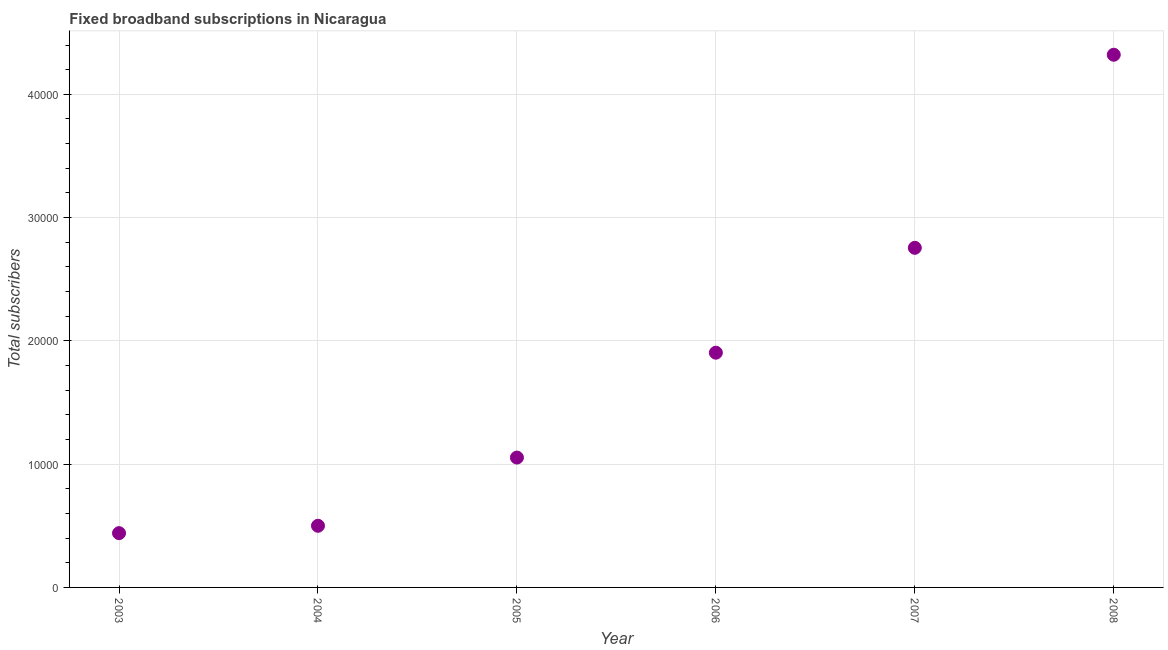What is the total number of fixed broadband subscriptions in 2008?
Your answer should be compact. 4.32e+04. Across all years, what is the maximum total number of fixed broadband subscriptions?
Give a very brief answer. 4.32e+04. Across all years, what is the minimum total number of fixed broadband subscriptions?
Keep it short and to the point. 4403. In which year was the total number of fixed broadband subscriptions maximum?
Your response must be concise. 2008. In which year was the total number of fixed broadband subscriptions minimum?
Give a very brief answer. 2003. What is the sum of the total number of fixed broadband subscriptions?
Provide a short and direct response. 1.10e+05. What is the difference between the total number of fixed broadband subscriptions in 2003 and 2006?
Offer a terse response. -1.46e+04. What is the average total number of fixed broadband subscriptions per year?
Make the answer very short. 1.83e+04. What is the median total number of fixed broadband subscriptions?
Your answer should be compact. 1.48e+04. What is the ratio of the total number of fixed broadband subscriptions in 2003 to that in 2004?
Provide a succinct answer. 0.88. Is the total number of fixed broadband subscriptions in 2004 less than that in 2007?
Your response must be concise. Yes. Is the difference between the total number of fixed broadband subscriptions in 2003 and 2008 greater than the difference between any two years?
Keep it short and to the point. Yes. What is the difference between the highest and the second highest total number of fixed broadband subscriptions?
Ensure brevity in your answer.  1.57e+04. What is the difference between the highest and the lowest total number of fixed broadband subscriptions?
Give a very brief answer. 3.88e+04. In how many years, is the total number of fixed broadband subscriptions greater than the average total number of fixed broadband subscriptions taken over all years?
Your response must be concise. 3. What is the difference between two consecutive major ticks on the Y-axis?
Provide a short and direct response. 10000. Are the values on the major ticks of Y-axis written in scientific E-notation?
Provide a short and direct response. No. What is the title of the graph?
Offer a very short reply. Fixed broadband subscriptions in Nicaragua. What is the label or title of the X-axis?
Ensure brevity in your answer.  Year. What is the label or title of the Y-axis?
Provide a succinct answer. Total subscribers. What is the Total subscribers in 2003?
Your answer should be very brief. 4403. What is the Total subscribers in 2004?
Offer a very short reply. 5001. What is the Total subscribers in 2005?
Make the answer very short. 1.05e+04. What is the Total subscribers in 2006?
Provide a succinct answer. 1.90e+04. What is the Total subscribers in 2007?
Offer a terse response. 2.76e+04. What is the Total subscribers in 2008?
Provide a short and direct response. 4.32e+04. What is the difference between the Total subscribers in 2003 and 2004?
Offer a terse response. -598. What is the difference between the Total subscribers in 2003 and 2005?
Ensure brevity in your answer.  -6131. What is the difference between the Total subscribers in 2003 and 2006?
Offer a terse response. -1.46e+04. What is the difference between the Total subscribers in 2003 and 2007?
Offer a terse response. -2.31e+04. What is the difference between the Total subscribers in 2003 and 2008?
Give a very brief answer. -3.88e+04. What is the difference between the Total subscribers in 2004 and 2005?
Offer a very short reply. -5533. What is the difference between the Total subscribers in 2004 and 2006?
Make the answer very short. -1.40e+04. What is the difference between the Total subscribers in 2004 and 2007?
Ensure brevity in your answer.  -2.25e+04. What is the difference between the Total subscribers in 2004 and 2008?
Your response must be concise. -3.82e+04. What is the difference between the Total subscribers in 2005 and 2006?
Keep it short and to the point. -8508. What is the difference between the Total subscribers in 2005 and 2007?
Your answer should be compact. -1.70e+04. What is the difference between the Total subscribers in 2005 and 2008?
Give a very brief answer. -3.27e+04. What is the difference between the Total subscribers in 2006 and 2007?
Provide a succinct answer. -8508. What is the difference between the Total subscribers in 2006 and 2008?
Offer a terse response. -2.42e+04. What is the difference between the Total subscribers in 2007 and 2008?
Keep it short and to the point. -1.57e+04. What is the ratio of the Total subscribers in 2003 to that in 2004?
Your answer should be very brief. 0.88. What is the ratio of the Total subscribers in 2003 to that in 2005?
Give a very brief answer. 0.42. What is the ratio of the Total subscribers in 2003 to that in 2006?
Provide a short and direct response. 0.23. What is the ratio of the Total subscribers in 2003 to that in 2007?
Make the answer very short. 0.16. What is the ratio of the Total subscribers in 2003 to that in 2008?
Make the answer very short. 0.1. What is the ratio of the Total subscribers in 2004 to that in 2005?
Offer a terse response. 0.47. What is the ratio of the Total subscribers in 2004 to that in 2006?
Make the answer very short. 0.26. What is the ratio of the Total subscribers in 2004 to that in 2007?
Offer a very short reply. 0.18. What is the ratio of the Total subscribers in 2004 to that in 2008?
Make the answer very short. 0.12. What is the ratio of the Total subscribers in 2005 to that in 2006?
Your response must be concise. 0.55. What is the ratio of the Total subscribers in 2005 to that in 2007?
Make the answer very short. 0.38. What is the ratio of the Total subscribers in 2005 to that in 2008?
Offer a terse response. 0.24. What is the ratio of the Total subscribers in 2006 to that in 2007?
Provide a succinct answer. 0.69. What is the ratio of the Total subscribers in 2006 to that in 2008?
Give a very brief answer. 0.44. What is the ratio of the Total subscribers in 2007 to that in 2008?
Your answer should be very brief. 0.64. 